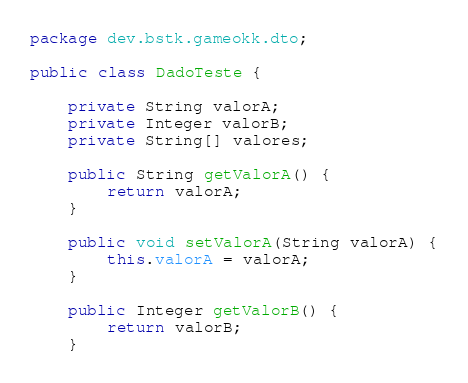<code> <loc_0><loc_0><loc_500><loc_500><_Java_>package dev.bstk.gameokk.dto;

public class DadoTeste {

    private String valorA;
    private Integer valorB;
    private String[] valores;

    public String getValorA() {
        return valorA;
    }

    public void setValorA(String valorA) {
        this.valorA = valorA;
    }

    public Integer getValorB() {
        return valorB;
    }
</code> 